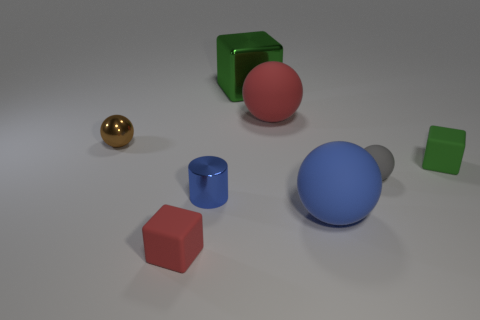There is a red thing that is behind the rubber block that is in front of the tiny ball in front of the tiny brown metal object; what is its size?
Give a very brief answer. Large. There is a green shiny block; is it the same size as the green cube in front of the tiny brown ball?
Keep it short and to the point. No. The tiny rubber block on the right side of the large metal thing is what color?
Your answer should be very brief. Green. What is the shape of the large matte object that is the same color as the cylinder?
Make the answer very short. Sphere. What is the shape of the rubber thing that is to the left of the metallic cylinder?
Your answer should be compact. Cube. What number of gray things are rubber objects or cylinders?
Give a very brief answer. 1. Are the small brown ball and the large red object made of the same material?
Your response must be concise. No. There is a brown shiny thing; what number of big green metal blocks are to the right of it?
Ensure brevity in your answer.  1. What is the block that is in front of the large green thing and on the left side of the blue rubber thing made of?
Keep it short and to the point. Rubber. How many cylinders are tiny brown things or small metallic objects?
Provide a succinct answer. 1. 